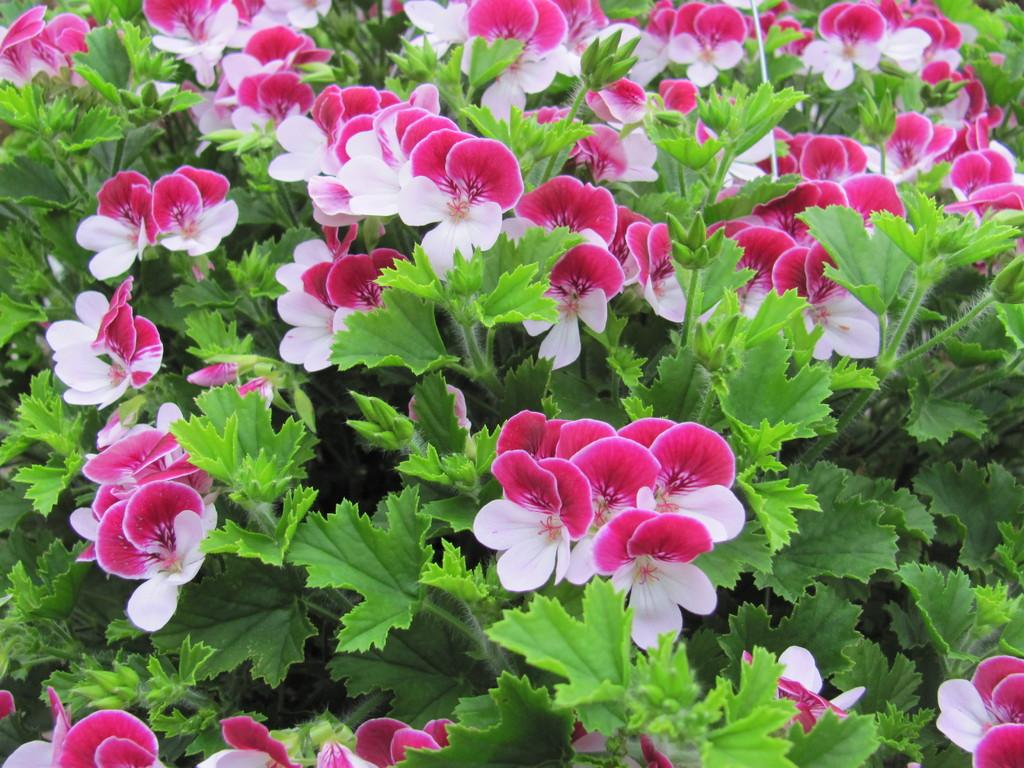What type of living organisms can be seen in the image? There is a group of plants in the image. What specific part of the plants are visible in the image? There are flowers in the image. What type of brick structure can be seen in the image? There is no brick structure present in the image; it only features a group of plants with flowers. What day of the week is depicted in the image? The image does not depict a specific day of the week; it only shows plants and flowers. 